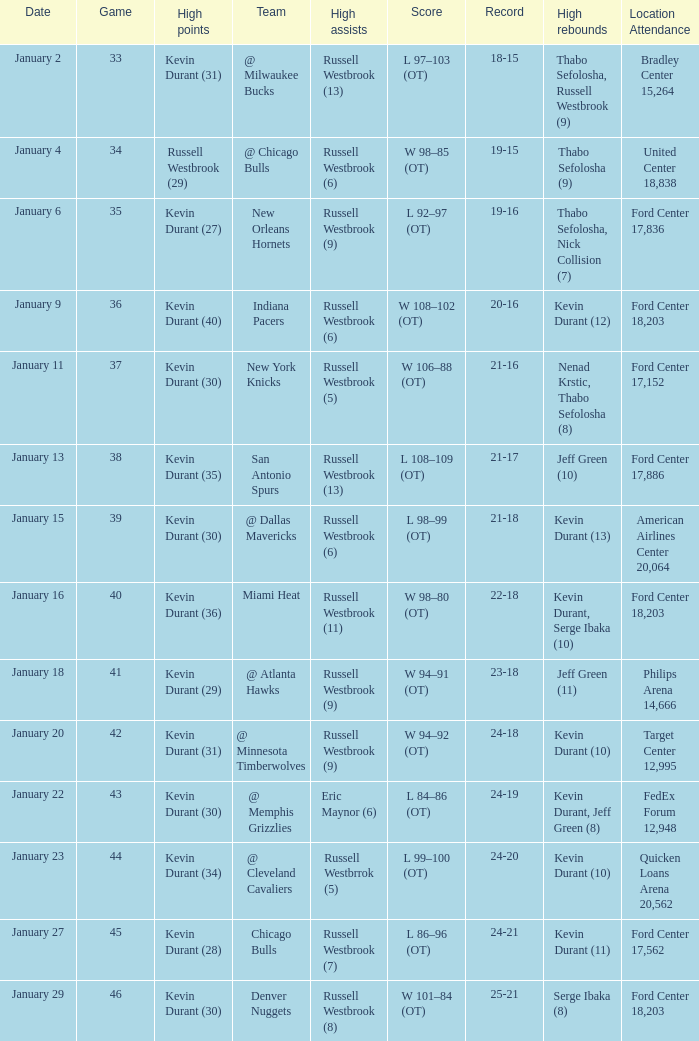Name the team for january 4 @ Chicago Bulls. 